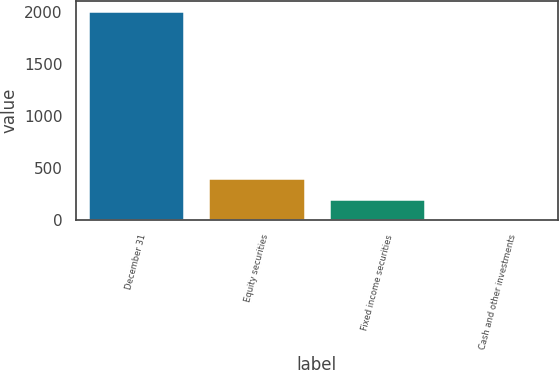Convert chart. <chart><loc_0><loc_0><loc_500><loc_500><bar_chart><fcel>December 31<fcel>Equity securities<fcel>Fixed income securities<fcel>Cash and other investments<nl><fcel>2013<fcel>404.2<fcel>203.1<fcel>2<nl></chart> 